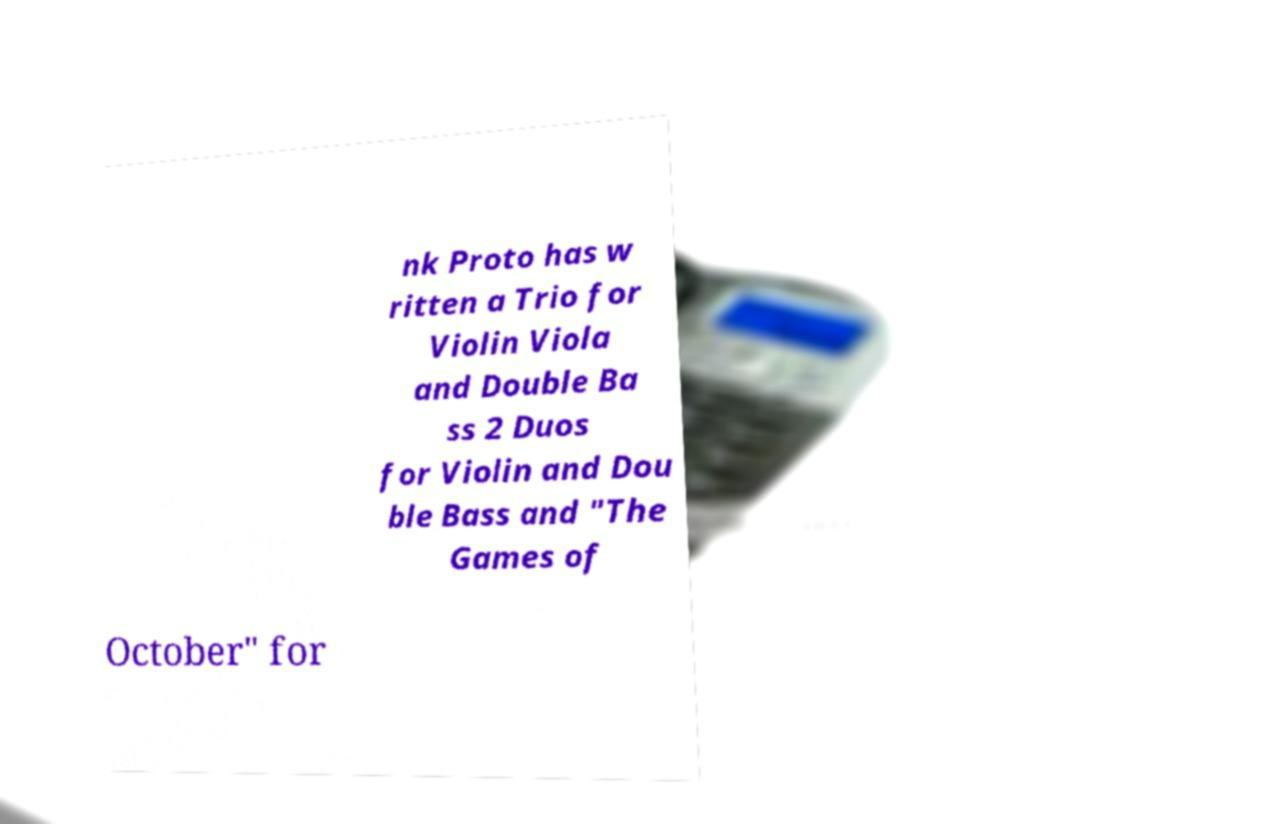Could you extract and type out the text from this image? nk Proto has w ritten a Trio for Violin Viola and Double Ba ss 2 Duos for Violin and Dou ble Bass and "The Games of October" for 